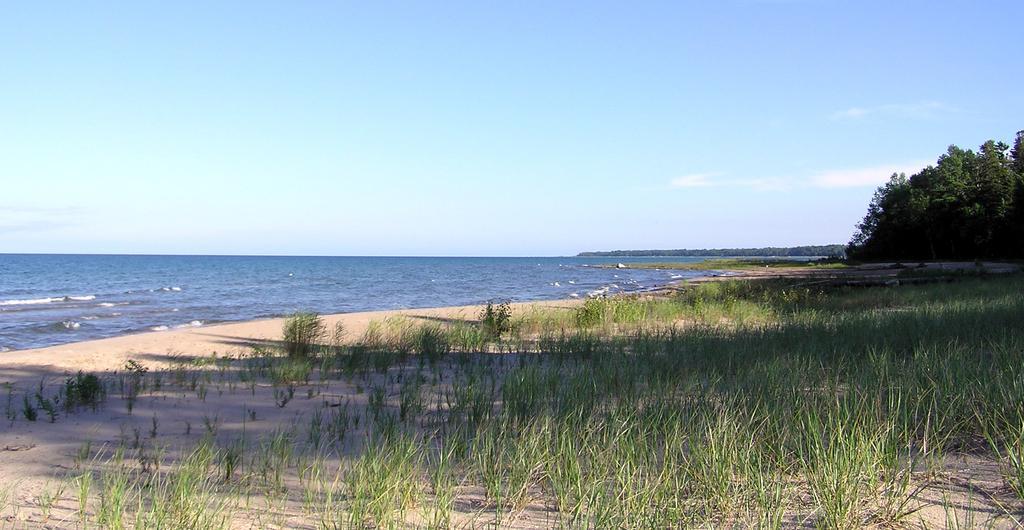Please provide a concise description of this image. In this picture, there is an ocean towards the left. Towards the right, there is a land with grass. Towards the right corner, there are trees. On the top, there is a sky. 